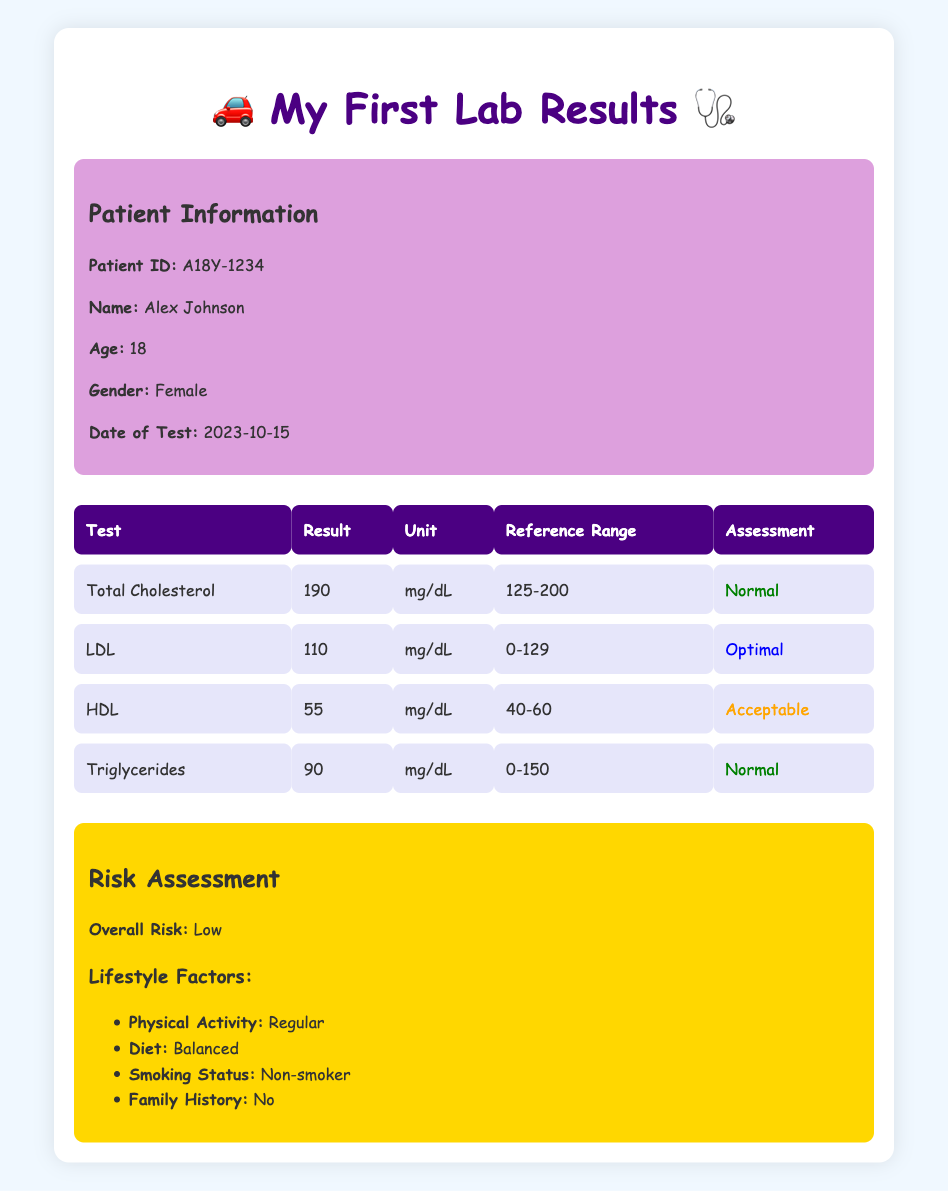What is Alex Johnson's total cholesterol level? The table shows a row labeled "Total Cholesterol" with a value of 190 in the corresponding result column.
Answer: 190 mg/dL What is the assessment of Alex's LDL cholesterol? The table indicates that the LDL cholesterol value is 110 mg/dL, and the assessment given in the final column is "Optimal."
Answer: Optimal Is Alex's HDL level acceptable according to the reference range? The HDL level is reported as 55 mg/dL. The reference range is from 40 to 60 mg/dL, and since 55 falls within this range, the answer is yes.
Answer: Yes What is the difference between Alex's LDL and HDL cholesterol levels? The LDL level is 110 mg/dL and the HDL level is 55 mg/dL. To find the difference, we subtract the HDL level from the LDL level: 110 - 55 = 55 mg/dL.
Answer: 55 mg/dL What lifestyle factor indicates that Alex has a healthier lifestyle? The table states that Alex has "Regular" physical activity, "Balanced" diet, "Non-smoker" status, and "No" family history. All these factors contribute to a healthier lifestyle, but "Regular" physical activity is a significant indicator.
Answer: Regular physical activity Was Alex's overall risk category rated high? The overall risk category is listed as "Low" in the risk assessment section. Therefore, the response to this question is no.
Answer: No What is the average triglyceride level compared to the maximum reference range? Alex's triglyceride level is 90 mg/dL, and the maximum reference range is 150 mg/dL. To find the average, we just consider Alex’s level since there's only one value: average = 90/150 = 0.6. This means Alex’s level is 60% of the maximum reference range.
Answer: 60% What would happen to Alex's overall risk assessment if she started smoking? The risk assessment currently indicates "Low" risk, and since smoking is identified as a negative lifestyle factor, introducing smoking would likely increase her overall risk level. While it can't be quantified exactly from the table, it would likely change from low to something higher.
Answer: It would likely increase her overall risk 